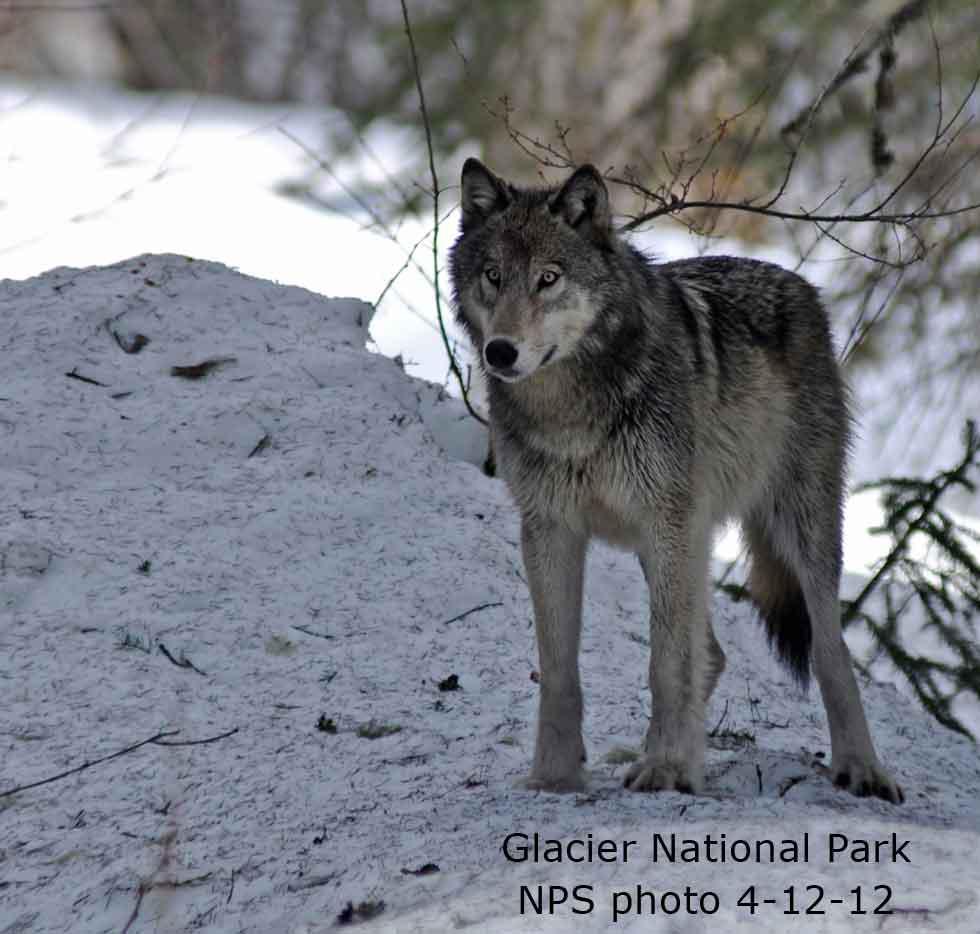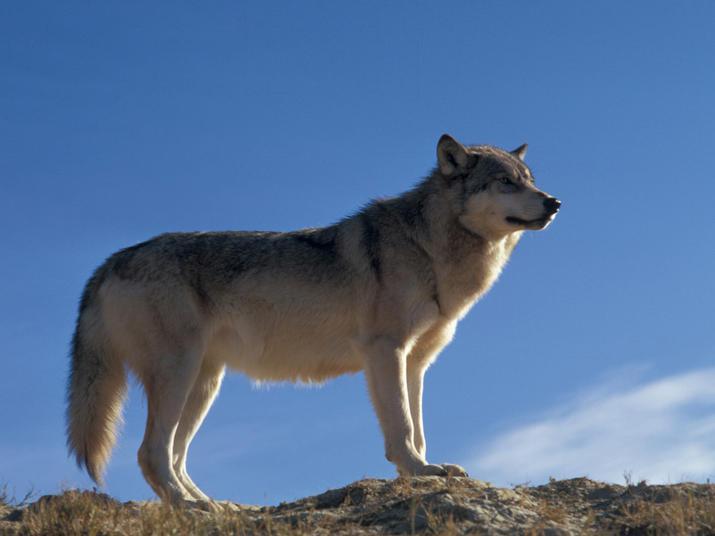The first image is the image on the left, the second image is the image on the right. Given the left and right images, does the statement "At least one of the wolves is visibly standing on snow." hold true? Answer yes or no. Yes. 